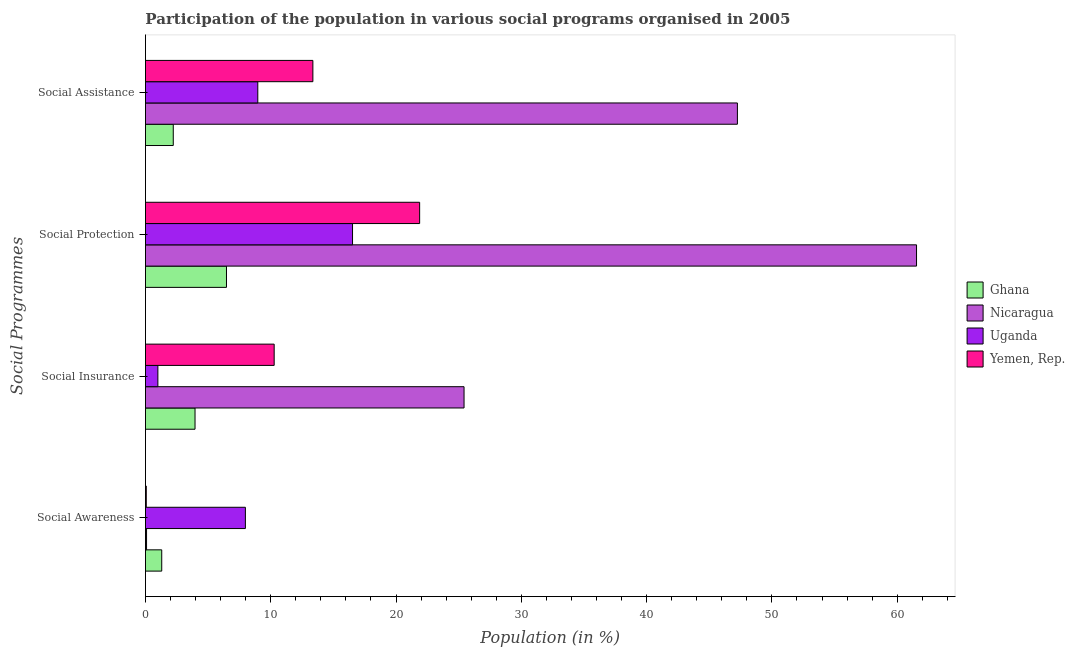How many bars are there on the 2nd tick from the top?
Provide a short and direct response. 4. How many bars are there on the 1st tick from the bottom?
Keep it short and to the point. 4. What is the label of the 3rd group of bars from the top?
Your answer should be compact. Social Insurance. What is the participation of population in social assistance programs in Uganda?
Make the answer very short. 8.97. Across all countries, what is the maximum participation of population in social assistance programs?
Provide a short and direct response. 47.25. Across all countries, what is the minimum participation of population in social insurance programs?
Your answer should be compact. 0.99. In which country was the participation of population in social assistance programs maximum?
Your answer should be very brief. Nicaragua. In which country was the participation of population in social awareness programs minimum?
Offer a very short reply. Yemen, Rep. What is the total participation of population in social protection programs in the graph?
Provide a succinct answer. 106.43. What is the difference between the participation of population in social insurance programs in Uganda and that in Ghana?
Your answer should be compact. -2.97. What is the difference between the participation of population in social protection programs in Yemen, Rep. and the participation of population in social assistance programs in Ghana?
Make the answer very short. 19.66. What is the average participation of population in social insurance programs per country?
Give a very brief answer. 10.16. What is the difference between the participation of population in social awareness programs and participation of population in social insurance programs in Yemen, Rep.?
Provide a succinct answer. -10.21. What is the ratio of the participation of population in social assistance programs in Ghana to that in Nicaragua?
Provide a succinct answer. 0.05. Is the participation of population in social awareness programs in Nicaragua less than that in Yemen, Rep.?
Offer a very short reply. No. What is the difference between the highest and the second highest participation of population in social insurance programs?
Offer a very short reply. 15.16. What is the difference between the highest and the lowest participation of population in social insurance programs?
Offer a terse response. 24.44. In how many countries, is the participation of population in social awareness programs greater than the average participation of population in social awareness programs taken over all countries?
Provide a short and direct response. 1. What does the 1st bar from the top in Social Insurance represents?
Provide a short and direct response. Yemen, Rep. What does the 2nd bar from the bottom in Social Awareness represents?
Give a very brief answer. Nicaragua. What is the difference between two consecutive major ticks on the X-axis?
Your answer should be very brief. 10. Does the graph contain grids?
Make the answer very short. No. What is the title of the graph?
Give a very brief answer. Participation of the population in various social programs organised in 2005. What is the label or title of the Y-axis?
Ensure brevity in your answer.  Social Programmes. What is the Population (in %) in Ghana in Social Awareness?
Provide a short and direct response. 1.3. What is the Population (in %) of Nicaragua in Social Awareness?
Make the answer very short. 0.09. What is the Population (in %) in Uganda in Social Awareness?
Offer a very short reply. 7.98. What is the Population (in %) of Yemen, Rep. in Social Awareness?
Provide a succinct answer. 0.07. What is the Population (in %) of Ghana in Social Insurance?
Ensure brevity in your answer.  3.96. What is the Population (in %) in Nicaragua in Social Insurance?
Keep it short and to the point. 25.43. What is the Population (in %) of Uganda in Social Insurance?
Your response must be concise. 0.99. What is the Population (in %) of Yemen, Rep. in Social Insurance?
Offer a very short reply. 10.27. What is the Population (in %) of Ghana in Social Protection?
Keep it short and to the point. 6.47. What is the Population (in %) in Nicaragua in Social Protection?
Provide a short and direct response. 61.55. What is the Population (in %) in Uganda in Social Protection?
Provide a short and direct response. 16.53. What is the Population (in %) of Yemen, Rep. in Social Protection?
Make the answer very short. 21.88. What is the Population (in %) in Ghana in Social Assistance?
Your answer should be very brief. 2.22. What is the Population (in %) in Nicaragua in Social Assistance?
Offer a terse response. 47.25. What is the Population (in %) in Uganda in Social Assistance?
Keep it short and to the point. 8.97. What is the Population (in %) of Yemen, Rep. in Social Assistance?
Your answer should be very brief. 13.36. Across all Social Programmes, what is the maximum Population (in %) of Ghana?
Provide a succinct answer. 6.47. Across all Social Programmes, what is the maximum Population (in %) of Nicaragua?
Your answer should be compact. 61.55. Across all Social Programmes, what is the maximum Population (in %) of Uganda?
Your response must be concise. 16.53. Across all Social Programmes, what is the maximum Population (in %) in Yemen, Rep.?
Give a very brief answer. 21.88. Across all Social Programmes, what is the minimum Population (in %) of Ghana?
Offer a very short reply. 1.3. Across all Social Programmes, what is the minimum Population (in %) in Nicaragua?
Ensure brevity in your answer.  0.09. Across all Social Programmes, what is the minimum Population (in %) of Uganda?
Offer a very short reply. 0.99. Across all Social Programmes, what is the minimum Population (in %) in Yemen, Rep.?
Offer a very short reply. 0.07. What is the total Population (in %) of Ghana in the graph?
Your response must be concise. 13.94. What is the total Population (in %) of Nicaragua in the graph?
Give a very brief answer. 134.31. What is the total Population (in %) of Uganda in the graph?
Ensure brevity in your answer.  34.46. What is the total Population (in %) of Yemen, Rep. in the graph?
Give a very brief answer. 45.59. What is the difference between the Population (in %) in Ghana in Social Awareness and that in Social Insurance?
Your response must be concise. -2.66. What is the difference between the Population (in %) of Nicaragua in Social Awareness and that in Social Insurance?
Provide a short and direct response. -25.34. What is the difference between the Population (in %) of Uganda in Social Awareness and that in Social Insurance?
Keep it short and to the point. 6.99. What is the difference between the Population (in %) in Yemen, Rep. in Social Awareness and that in Social Insurance?
Keep it short and to the point. -10.21. What is the difference between the Population (in %) in Ghana in Social Awareness and that in Social Protection?
Keep it short and to the point. -5.17. What is the difference between the Population (in %) of Nicaragua in Social Awareness and that in Social Protection?
Give a very brief answer. -61.46. What is the difference between the Population (in %) in Uganda in Social Awareness and that in Social Protection?
Give a very brief answer. -8.55. What is the difference between the Population (in %) in Yemen, Rep. in Social Awareness and that in Social Protection?
Give a very brief answer. -21.82. What is the difference between the Population (in %) of Ghana in Social Awareness and that in Social Assistance?
Your answer should be very brief. -0.92. What is the difference between the Population (in %) in Nicaragua in Social Awareness and that in Social Assistance?
Give a very brief answer. -47.16. What is the difference between the Population (in %) in Uganda in Social Awareness and that in Social Assistance?
Provide a succinct answer. -0.99. What is the difference between the Population (in %) in Yemen, Rep. in Social Awareness and that in Social Assistance?
Offer a very short reply. -13.3. What is the difference between the Population (in %) in Ghana in Social Insurance and that in Social Protection?
Your answer should be very brief. -2.51. What is the difference between the Population (in %) of Nicaragua in Social Insurance and that in Social Protection?
Make the answer very short. -36.12. What is the difference between the Population (in %) in Uganda in Social Insurance and that in Social Protection?
Keep it short and to the point. -15.54. What is the difference between the Population (in %) in Yemen, Rep. in Social Insurance and that in Social Protection?
Offer a terse response. -11.61. What is the difference between the Population (in %) of Ghana in Social Insurance and that in Social Assistance?
Make the answer very short. 1.74. What is the difference between the Population (in %) in Nicaragua in Social Insurance and that in Social Assistance?
Ensure brevity in your answer.  -21.82. What is the difference between the Population (in %) of Uganda in Social Insurance and that in Social Assistance?
Give a very brief answer. -7.98. What is the difference between the Population (in %) of Yemen, Rep. in Social Insurance and that in Social Assistance?
Give a very brief answer. -3.09. What is the difference between the Population (in %) of Ghana in Social Protection and that in Social Assistance?
Offer a very short reply. 4.25. What is the difference between the Population (in %) in Nicaragua in Social Protection and that in Social Assistance?
Give a very brief answer. 14.3. What is the difference between the Population (in %) of Uganda in Social Protection and that in Social Assistance?
Give a very brief answer. 7.56. What is the difference between the Population (in %) of Yemen, Rep. in Social Protection and that in Social Assistance?
Make the answer very short. 8.52. What is the difference between the Population (in %) in Ghana in Social Awareness and the Population (in %) in Nicaragua in Social Insurance?
Your answer should be compact. -24.13. What is the difference between the Population (in %) in Ghana in Social Awareness and the Population (in %) in Uganda in Social Insurance?
Keep it short and to the point. 0.31. What is the difference between the Population (in %) of Ghana in Social Awareness and the Population (in %) of Yemen, Rep. in Social Insurance?
Your response must be concise. -8.97. What is the difference between the Population (in %) in Nicaragua in Social Awareness and the Population (in %) in Uganda in Social Insurance?
Offer a terse response. -0.9. What is the difference between the Population (in %) of Nicaragua in Social Awareness and the Population (in %) of Yemen, Rep. in Social Insurance?
Offer a terse response. -10.19. What is the difference between the Population (in %) in Uganda in Social Awareness and the Population (in %) in Yemen, Rep. in Social Insurance?
Your response must be concise. -2.3. What is the difference between the Population (in %) in Ghana in Social Awareness and the Population (in %) in Nicaragua in Social Protection?
Make the answer very short. -60.25. What is the difference between the Population (in %) of Ghana in Social Awareness and the Population (in %) of Uganda in Social Protection?
Keep it short and to the point. -15.23. What is the difference between the Population (in %) in Ghana in Social Awareness and the Population (in %) in Yemen, Rep. in Social Protection?
Make the answer very short. -20.59. What is the difference between the Population (in %) in Nicaragua in Social Awareness and the Population (in %) in Uganda in Social Protection?
Provide a short and direct response. -16.44. What is the difference between the Population (in %) of Nicaragua in Social Awareness and the Population (in %) of Yemen, Rep. in Social Protection?
Your answer should be very brief. -21.8. What is the difference between the Population (in %) of Uganda in Social Awareness and the Population (in %) of Yemen, Rep. in Social Protection?
Offer a very short reply. -13.91. What is the difference between the Population (in %) of Ghana in Social Awareness and the Population (in %) of Nicaragua in Social Assistance?
Keep it short and to the point. -45.95. What is the difference between the Population (in %) of Ghana in Social Awareness and the Population (in %) of Uganda in Social Assistance?
Your answer should be compact. -7.67. What is the difference between the Population (in %) in Ghana in Social Awareness and the Population (in %) in Yemen, Rep. in Social Assistance?
Make the answer very short. -12.06. What is the difference between the Population (in %) in Nicaragua in Social Awareness and the Population (in %) in Uganda in Social Assistance?
Make the answer very short. -8.88. What is the difference between the Population (in %) of Nicaragua in Social Awareness and the Population (in %) of Yemen, Rep. in Social Assistance?
Your answer should be compact. -13.28. What is the difference between the Population (in %) of Uganda in Social Awareness and the Population (in %) of Yemen, Rep. in Social Assistance?
Your response must be concise. -5.39. What is the difference between the Population (in %) in Ghana in Social Insurance and the Population (in %) in Nicaragua in Social Protection?
Your answer should be very brief. -57.59. What is the difference between the Population (in %) of Ghana in Social Insurance and the Population (in %) of Uganda in Social Protection?
Make the answer very short. -12.57. What is the difference between the Population (in %) of Ghana in Social Insurance and the Population (in %) of Yemen, Rep. in Social Protection?
Provide a short and direct response. -17.93. What is the difference between the Population (in %) of Nicaragua in Social Insurance and the Population (in %) of Uganda in Social Protection?
Provide a succinct answer. 8.9. What is the difference between the Population (in %) of Nicaragua in Social Insurance and the Population (in %) of Yemen, Rep. in Social Protection?
Provide a succinct answer. 3.54. What is the difference between the Population (in %) of Uganda in Social Insurance and the Population (in %) of Yemen, Rep. in Social Protection?
Give a very brief answer. -20.89. What is the difference between the Population (in %) in Ghana in Social Insurance and the Population (in %) in Nicaragua in Social Assistance?
Provide a short and direct response. -43.29. What is the difference between the Population (in %) in Ghana in Social Insurance and the Population (in %) in Uganda in Social Assistance?
Offer a terse response. -5.01. What is the difference between the Population (in %) of Ghana in Social Insurance and the Population (in %) of Yemen, Rep. in Social Assistance?
Your response must be concise. -9.41. What is the difference between the Population (in %) of Nicaragua in Social Insurance and the Population (in %) of Uganda in Social Assistance?
Your answer should be very brief. 16.46. What is the difference between the Population (in %) of Nicaragua in Social Insurance and the Population (in %) of Yemen, Rep. in Social Assistance?
Give a very brief answer. 12.07. What is the difference between the Population (in %) in Uganda in Social Insurance and the Population (in %) in Yemen, Rep. in Social Assistance?
Your answer should be compact. -12.37. What is the difference between the Population (in %) in Ghana in Social Protection and the Population (in %) in Nicaragua in Social Assistance?
Your answer should be very brief. -40.78. What is the difference between the Population (in %) of Ghana in Social Protection and the Population (in %) of Uganda in Social Assistance?
Provide a short and direct response. -2.5. What is the difference between the Population (in %) in Ghana in Social Protection and the Population (in %) in Yemen, Rep. in Social Assistance?
Your answer should be very brief. -6.9. What is the difference between the Population (in %) in Nicaragua in Social Protection and the Population (in %) in Uganda in Social Assistance?
Make the answer very short. 52.58. What is the difference between the Population (in %) of Nicaragua in Social Protection and the Population (in %) of Yemen, Rep. in Social Assistance?
Your answer should be very brief. 48.18. What is the difference between the Population (in %) in Uganda in Social Protection and the Population (in %) in Yemen, Rep. in Social Assistance?
Make the answer very short. 3.17. What is the average Population (in %) in Ghana per Social Programmes?
Provide a short and direct response. 3.49. What is the average Population (in %) of Nicaragua per Social Programmes?
Provide a short and direct response. 33.58. What is the average Population (in %) of Uganda per Social Programmes?
Your answer should be compact. 8.62. What is the average Population (in %) of Yemen, Rep. per Social Programmes?
Make the answer very short. 11.4. What is the difference between the Population (in %) of Ghana and Population (in %) of Nicaragua in Social Awareness?
Your response must be concise. 1.21. What is the difference between the Population (in %) in Ghana and Population (in %) in Uganda in Social Awareness?
Your answer should be compact. -6.68. What is the difference between the Population (in %) of Ghana and Population (in %) of Yemen, Rep. in Social Awareness?
Your response must be concise. 1.23. What is the difference between the Population (in %) of Nicaragua and Population (in %) of Uganda in Social Awareness?
Ensure brevity in your answer.  -7.89. What is the difference between the Population (in %) of Nicaragua and Population (in %) of Yemen, Rep. in Social Awareness?
Offer a terse response. 0.02. What is the difference between the Population (in %) of Uganda and Population (in %) of Yemen, Rep. in Social Awareness?
Keep it short and to the point. 7.91. What is the difference between the Population (in %) in Ghana and Population (in %) in Nicaragua in Social Insurance?
Your response must be concise. -21.47. What is the difference between the Population (in %) in Ghana and Population (in %) in Uganda in Social Insurance?
Provide a succinct answer. 2.97. What is the difference between the Population (in %) of Ghana and Population (in %) of Yemen, Rep. in Social Insurance?
Provide a short and direct response. -6.32. What is the difference between the Population (in %) of Nicaragua and Population (in %) of Uganda in Social Insurance?
Provide a short and direct response. 24.44. What is the difference between the Population (in %) in Nicaragua and Population (in %) in Yemen, Rep. in Social Insurance?
Your answer should be compact. 15.16. What is the difference between the Population (in %) in Uganda and Population (in %) in Yemen, Rep. in Social Insurance?
Provide a succinct answer. -9.28. What is the difference between the Population (in %) of Ghana and Population (in %) of Nicaragua in Social Protection?
Give a very brief answer. -55.08. What is the difference between the Population (in %) of Ghana and Population (in %) of Uganda in Social Protection?
Your response must be concise. -10.06. What is the difference between the Population (in %) of Ghana and Population (in %) of Yemen, Rep. in Social Protection?
Offer a terse response. -15.42. What is the difference between the Population (in %) of Nicaragua and Population (in %) of Uganda in Social Protection?
Offer a terse response. 45.02. What is the difference between the Population (in %) of Nicaragua and Population (in %) of Yemen, Rep. in Social Protection?
Ensure brevity in your answer.  39.66. What is the difference between the Population (in %) of Uganda and Population (in %) of Yemen, Rep. in Social Protection?
Your response must be concise. -5.36. What is the difference between the Population (in %) in Ghana and Population (in %) in Nicaragua in Social Assistance?
Your response must be concise. -45.03. What is the difference between the Population (in %) in Ghana and Population (in %) in Uganda in Social Assistance?
Your answer should be compact. -6.75. What is the difference between the Population (in %) of Ghana and Population (in %) of Yemen, Rep. in Social Assistance?
Your answer should be compact. -11.14. What is the difference between the Population (in %) in Nicaragua and Population (in %) in Uganda in Social Assistance?
Offer a terse response. 38.28. What is the difference between the Population (in %) of Nicaragua and Population (in %) of Yemen, Rep. in Social Assistance?
Provide a succinct answer. 33.88. What is the difference between the Population (in %) of Uganda and Population (in %) of Yemen, Rep. in Social Assistance?
Your answer should be very brief. -4.4. What is the ratio of the Population (in %) of Ghana in Social Awareness to that in Social Insurance?
Offer a terse response. 0.33. What is the ratio of the Population (in %) of Nicaragua in Social Awareness to that in Social Insurance?
Offer a very short reply. 0. What is the ratio of the Population (in %) in Uganda in Social Awareness to that in Social Insurance?
Your answer should be compact. 8.05. What is the ratio of the Population (in %) of Yemen, Rep. in Social Awareness to that in Social Insurance?
Offer a terse response. 0.01. What is the ratio of the Population (in %) in Ghana in Social Awareness to that in Social Protection?
Your answer should be compact. 0.2. What is the ratio of the Population (in %) in Nicaragua in Social Awareness to that in Social Protection?
Offer a very short reply. 0. What is the ratio of the Population (in %) in Uganda in Social Awareness to that in Social Protection?
Give a very brief answer. 0.48. What is the ratio of the Population (in %) of Yemen, Rep. in Social Awareness to that in Social Protection?
Keep it short and to the point. 0. What is the ratio of the Population (in %) of Ghana in Social Awareness to that in Social Assistance?
Give a very brief answer. 0.59. What is the ratio of the Population (in %) in Nicaragua in Social Awareness to that in Social Assistance?
Provide a short and direct response. 0. What is the ratio of the Population (in %) in Uganda in Social Awareness to that in Social Assistance?
Your answer should be compact. 0.89. What is the ratio of the Population (in %) in Yemen, Rep. in Social Awareness to that in Social Assistance?
Your answer should be very brief. 0. What is the ratio of the Population (in %) in Ghana in Social Insurance to that in Social Protection?
Provide a short and direct response. 0.61. What is the ratio of the Population (in %) in Nicaragua in Social Insurance to that in Social Protection?
Make the answer very short. 0.41. What is the ratio of the Population (in %) in Uganda in Social Insurance to that in Social Protection?
Provide a short and direct response. 0.06. What is the ratio of the Population (in %) of Yemen, Rep. in Social Insurance to that in Social Protection?
Provide a short and direct response. 0.47. What is the ratio of the Population (in %) of Ghana in Social Insurance to that in Social Assistance?
Provide a short and direct response. 1.78. What is the ratio of the Population (in %) in Nicaragua in Social Insurance to that in Social Assistance?
Make the answer very short. 0.54. What is the ratio of the Population (in %) of Uganda in Social Insurance to that in Social Assistance?
Offer a very short reply. 0.11. What is the ratio of the Population (in %) of Yemen, Rep. in Social Insurance to that in Social Assistance?
Make the answer very short. 0.77. What is the ratio of the Population (in %) of Ghana in Social Protection to that in Social Assistance?
Give a very brief answer. 2.91. What is the ratio of the Population (in %) in Nicaragua in Social Protection to that in Social Assistance?
Ensure brevity in your answer.  1.3. What is the ratio of the Population (in %) of Uganda in Social Protection to that in Social Assistance?
Your response must be concise. 1.84. What is the ratio of the Population (in %) of Yemen, Rep. in Social Protection to that in Social Assistance?
Provide a succinct answer. 1.64. What is the difference between the highest and the second highest Population (in %) of Ghana?
Offer a terse response. 2.51. What is the difference between the highest and the second highest Population (in %) of Nicaragua?
Provide a short and direct response. 14.3. What is the difference between the highest and the second highest Population (in %) of Uganda?
Keep it short and to the point. 7.56. What is the difference between the highest and the second highest Population (in %) in Yemen, Rep.?
Your answer should be compact. 8.52. What is the difference between the highest and the lowest Population (in %) in Ghana?
Provide a succinct answer. 5.17. What is the difference between the highest and the lowest Population (in %) of Nicaragua?
Offer a very short reply. 61.46. What is the difference between the highest and the lowest Population (in %) of Uganda?
Ensure brevity in your answer.  15.54. What is the difference between the highest and the lowest Population (in %) in Yemen, Rep.?
Offer a terse response. 21.82. 